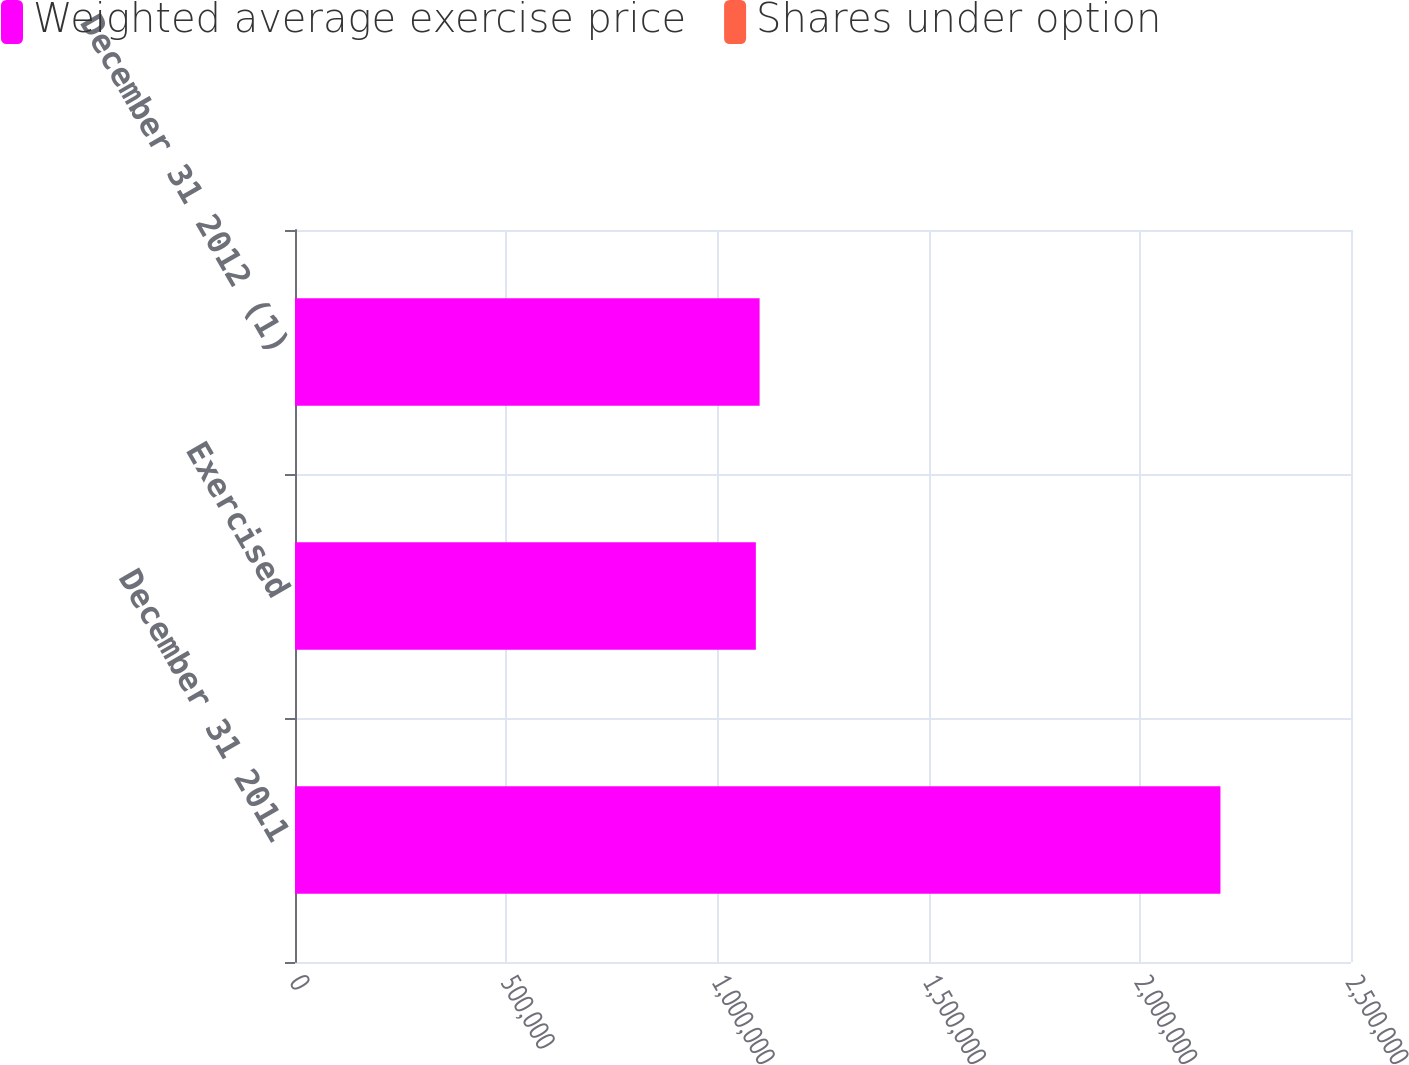<chart> <loc_0><loc_0><loc_500><loc_500><stacked_bar_chart><ecel><fcel>December 31 2011<fcel>Exercised<fcel>December 31 2012 (1)<nl><fcel>Weighted average exercise price<fcel>2.19091e+06<fcel>1.091e+06<fcel>1.09991e+06<nl><fcel>Shares under option<fcel>105.33<fcel>42.39<fcel>167.76<nl></chart> 